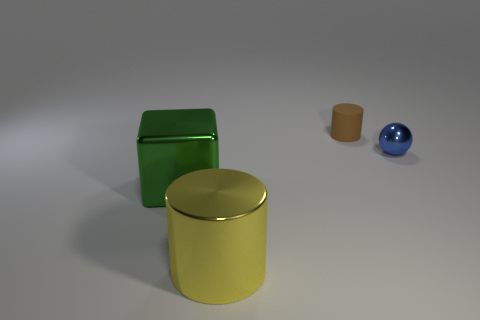Add 4 large green objects. How many objects exist? 8 Subtract all spheres. How many objects are left? 3 Add 4 metal cubes. How many metal cubes are left? 5 Add 4 small red matte balls. How many small red matte balls exist? 4 Subtract 0 yellow cubes. How many objects are left? 4 Subtract all tiny shiny objects. Subtract all big cylinders. How many objects are left? 2 